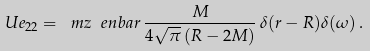<formula> <loc_0><loc_0><loc_500><loc_500>U e _ { 2 2 } = \ m z \ e n b a r \, \frac { M } { 4 \sqrt { \pi } \left ( R - 2 M \right ) } \, \delta ( r - R ) \delta ( \omega ) \, .</formula> 